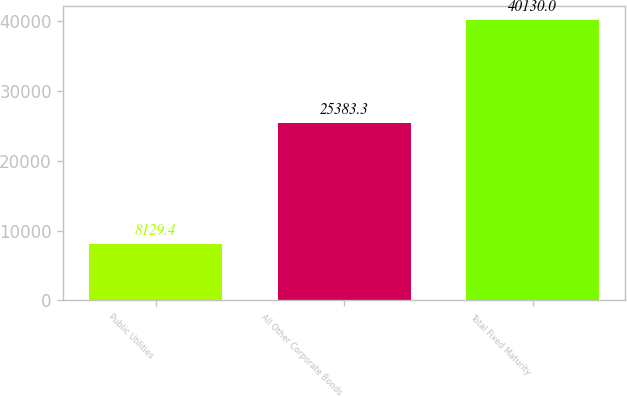Convert chart. <chart><loc_0><loc_0><loc_500><loc_500><bar_chart><fcel>Public Utilities<fcel>All Other Corporate Bonds<fcel>Total Fixed Maturity<nl><fcel>8129.4<fcel>25383.3<fcel>40130<nl></chart> 